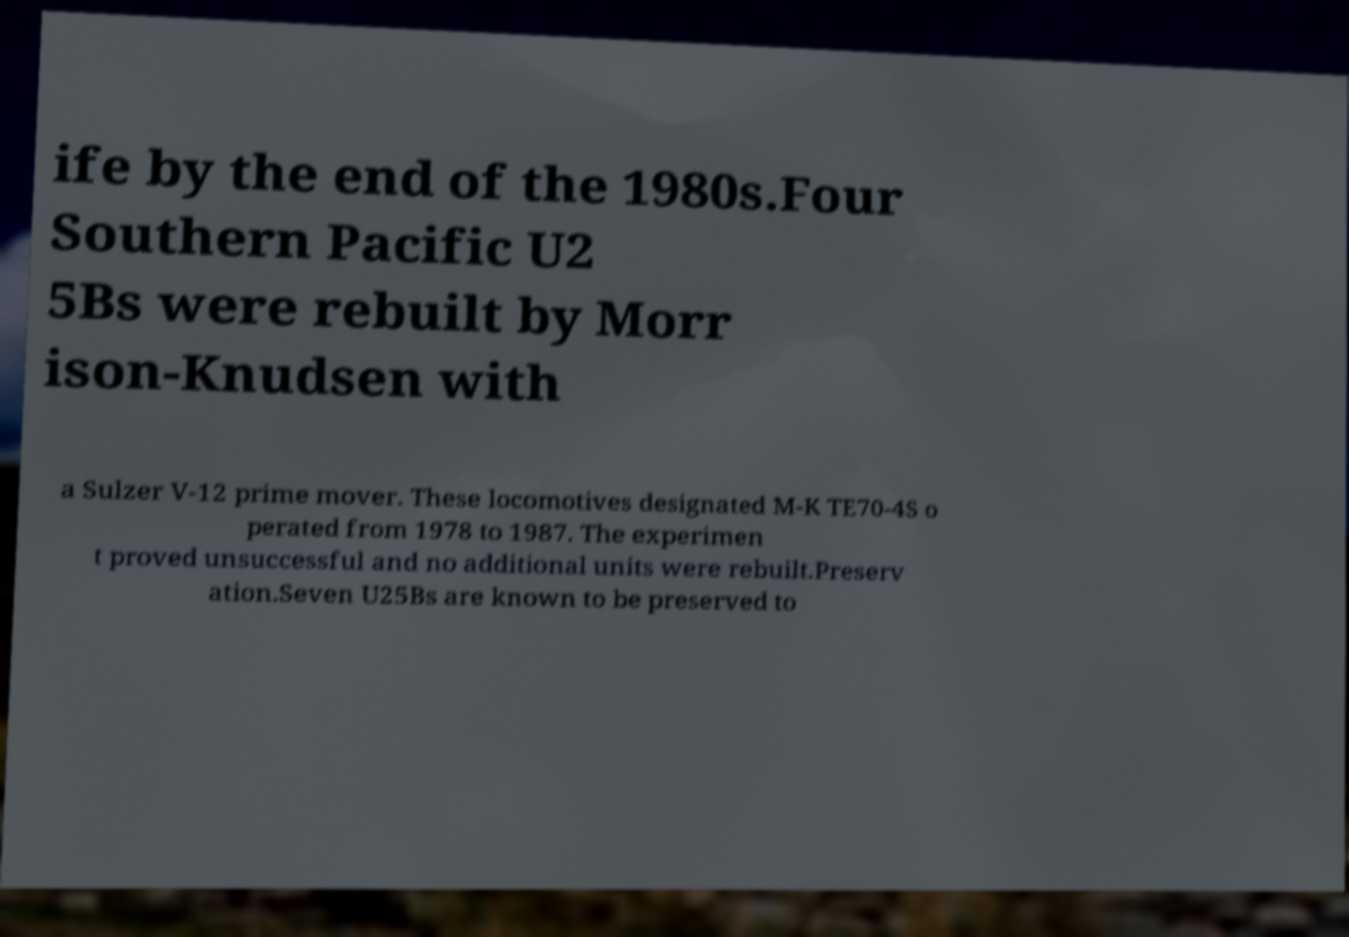Please read and relay the text visible in this image. What does it say? ife by the end of the 1980s.Four Southern Pacific U2 5Bs were rebuilt by Morr ison-Knudsen with a Sulzer V-12 prime mover. These locomotives designated M-K TE70-4S o perated from 1978 to 1987. The experimen t proved unsuccessful and no additional units were rebuilt.Preserv ation.Seven U25Bs are known to be preserved to 